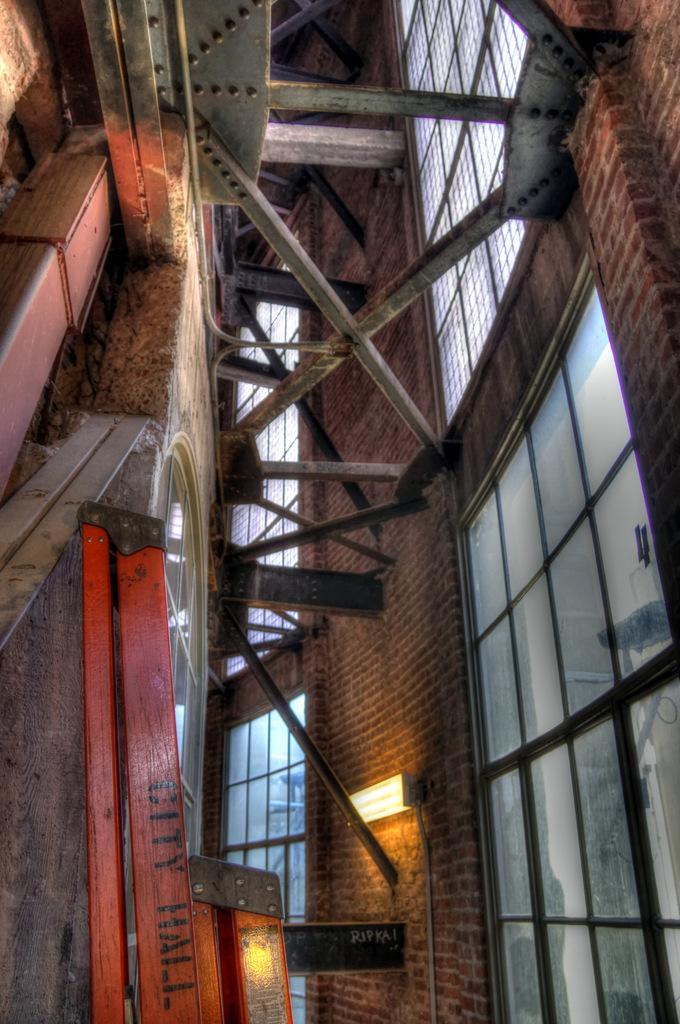Please provide a concise description of this image. In the image we can see this is an internal structure of the building, these are the windows made up of glass, there are wooden poles and a light. 